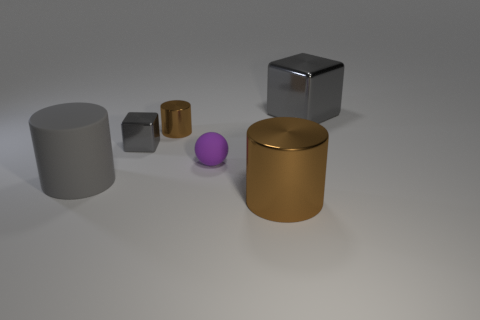Add 3 small yellow shiny objects. How many objects exist? 9 Subtract all cubes. How many objects are left? 4 Subtract all green cubes. Subtract all large rubber cylinders. How many objects are left? 5 Add 4 big matte cylinders. How many big matte cylinders are left? 5 Add 6 large metallic cylinders. How many large metallic cylinders exist? 7 Subtract 0 yellow cylinders. How many objects are left? 6 